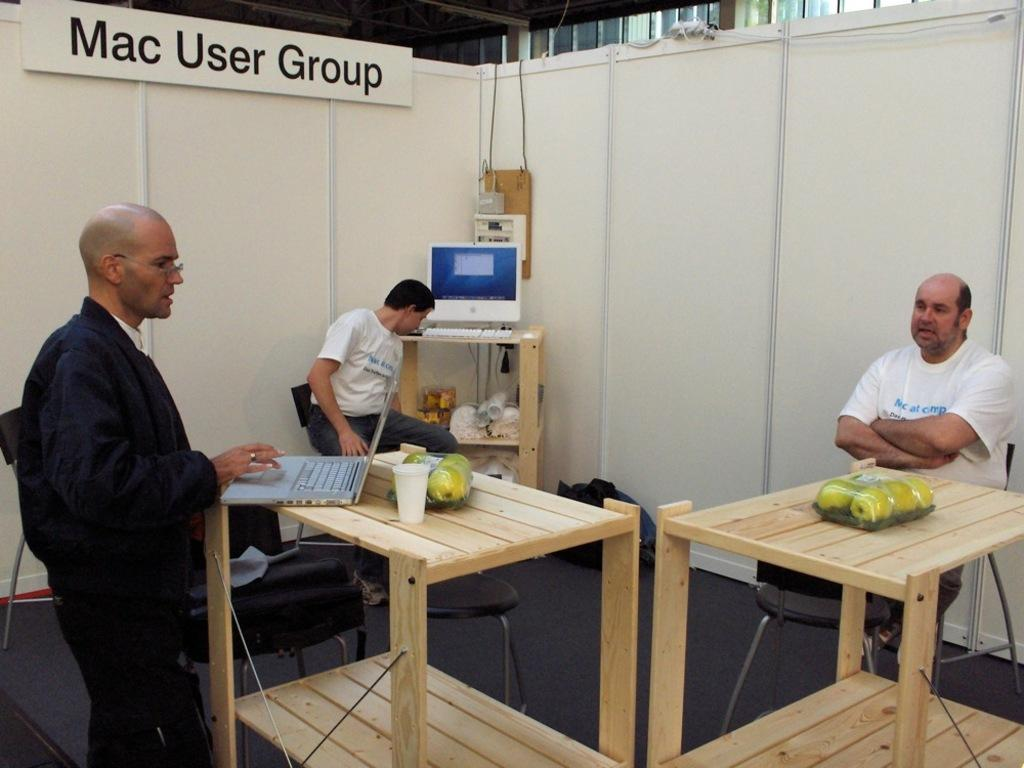<image>
Provide a brief description of the given image. Three men in a large cubicle with a sign above them saying Mac User Group. 